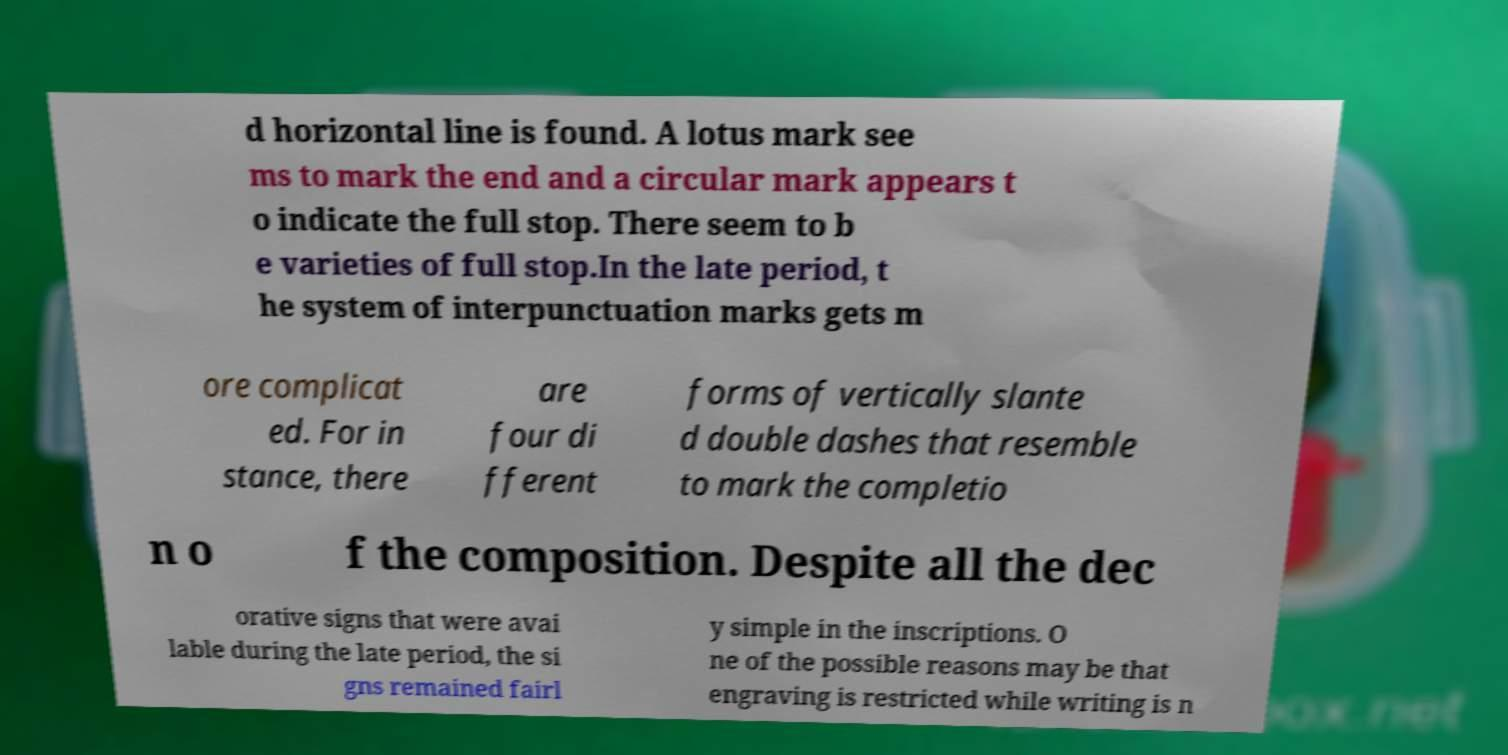There's text embedded in this image that I need extracted. Can you transcribe it verbatim? d horizontal line is found. A lotus mark see ms to mark the end and a circular mark appears t o indicate the full stop. There seem to b e varieties of full stop.In the late period, t he system of interpunctuation marks gets m ore complicat ed. For in stance, there are four di fferent forms of vertically slante d double dashes that resemble to mark the completio n o f the composition. Despite all the dec orative signs that were avai lable during the late period, the si gns remained fairl y simple in the inscriptions. O ne of the possible reasons may be that engraving is restricted while writing is n 